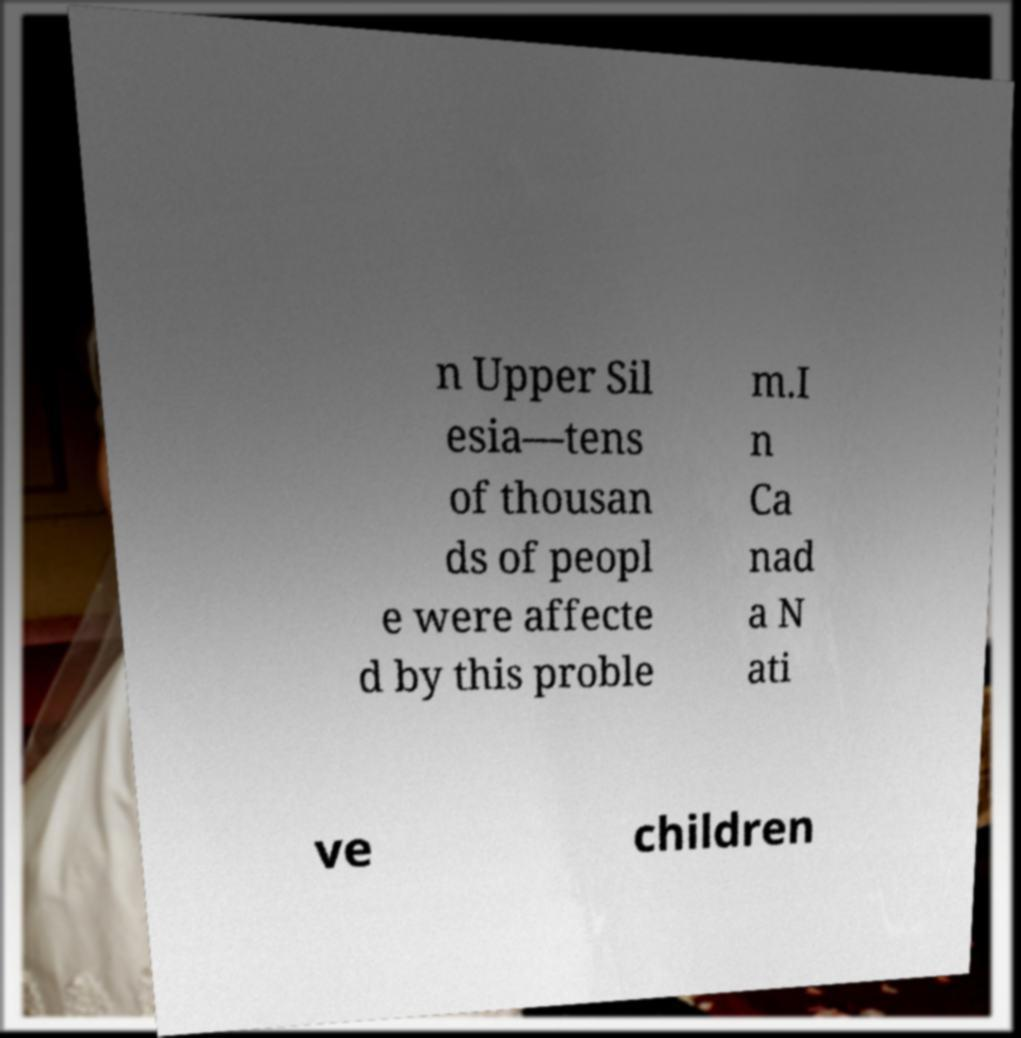Can you read and provide the text displayed in the image?This photo seems to have some interesting text. Can you extract and type it out for me? n Upper Sil esia—tens of thousan ds of peopl e were affecte d by this proble m.I n Ca nad a N ati ve children 